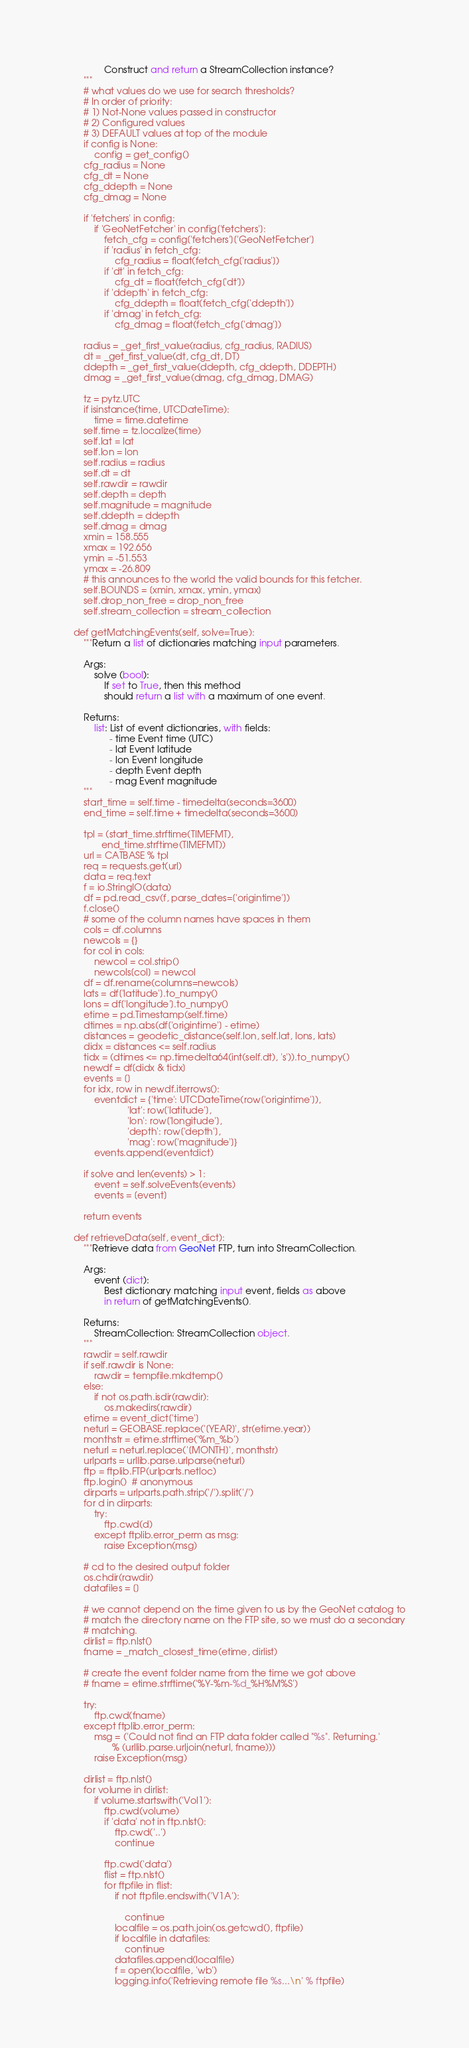Convert code to text. <code><loc_0><loc_0><loc_500><loc_500><_Python_>                Construct and return a StreamCollection instance?
        """
        # what values do we use for search thresholds?
        # In order of priority:
        # 1) Not-None values passed in constructor
        # 2) Configured values
        # 3) DEFAULT values at top of the module
        if config is None:
            config = get_config()
        cfg_radius = None
        cfg_dt = None
        cfg_ddepth = None
        cfg_dmag = None

        if 'fetchers' in config:
            if 'GeoNetFetcher' in config['fetchers']:
                fetch_cfg = config['fetchers']['GeoNetFetcher']
                if 'radius' in fetch_cfg:
                    cfg_radius = float(fetch_cfg['radius'])
                if 'dt' in fetch_cfg:
                    cfg_dt = float(fetch_cfg['dt'])
                if 'ddepth' in fetch_cfg:
                    cfg_ddepth = float(fetch_cfg['ddepth'])
                if 'dmag' in fetch_cfg:
                    cfg_dmag = float(fetch_cfg['dmag'])

        radius = _get_first_value(radius, cfg_radius, RADIUS)
        dt = _get_first_value(dt, cfg_dt, DT)
        ddepth = _get_first_value(ddepth, cfg_ddepth, DDEPTH)
        dmag = _get_first_value(dmag, cfg_dmag, DMAG)

        tz = pytz.UTC
        if isinstance(time, UTCDateTime):
            time = time.datetime
        self.time = tz.localize(time)
        self.lat = lat
        self.lon = lon
        self.radius = radius
        self.dt = dt
        self.rawdir = rawdir
        self.depth = depth
        self.magnitude = magnitude
        self.ddepth = ddepth
        self.dmag = dmag
        xmin = 158.555
        xmax = 192.656
        ymin = -51.553
        ymax = -26.809
        # this announces to the world the valid bounds for this fetcher.
        self.BOUNDS = [xmin, xmax, ymin, ymax]
        self.drop_non_free = drop_non_free
        self.stream_collection = stream_collection

    def getMatchingEvents(self, solve=True):
        """Return a list of dictionaries matching input parameters.

        Args:
            solve (bool):
                If set to True, then this method
                should return a list with a maximum of one event.

        Returns:
            list: List of event dictionaries, with fields:
                  - time Event time (UTC)
                  - lat Event latitude
                  - lon Event longitude
                  - depth Event depth
                  - mag Event magnitude
        """
        start_time = self.time - timedelta(seconds=3600)
        end_time = self.time + timedelta(seconds=3600)

        tpl = (start_time.strftime(TIMEFMT),
               end_time.strftime(TIMEFMT))
        url = CATBASE % tpl
        req = requests.get(url)
        data = req.text
        f = io.StringIO(data)
        df = pd.read_csv(f, parse_dates=['origintime'])
        f.close()
        # some of the column names have spaces in them
        cols = df.columns
        newcols = {}
        for col in cols:
            newcol = col.strip()
            newcols[col] = newcol
        df = df.rename(columns=newcols)
        lats = df['latitude'].to_numpy()
        lons = df['longitude'].to_numpy()
        etime = pd.Timestamp(self.time)
        dtimes = np.abs(df['origintime'] - etime)
        distances = geodetic_distance(self.lon, self.lat, lons, lats)
        didx = distances <= self.radius
        tidx = (dtimes <= np.timedelta64(int(self.dt), 's')).to_numpy()
        newdf = df[didx & tidx]
        events = []
        for idx, row in newdf.iterrows():
            eventdict = {'time': UTCDateTime(row['origintime']),
                         'lat': row['latitude'],
                         'lon': row['longitude'],
                         'depth': row['depth'],
                         'mag': row['magnitude']}
            events.append(eventdict)

        if solve and len(events) > 1:
            event = self.solveEvents(events)
            events = [event]

        return events

    def retrieveData(self, event_dict):
        """Retrieve data from GeoNet FTP, turn into StreamCollection.

        Args:
            event (dict):
                Best dictionary matching input event, fields as above
                in return of getMatchingEvents().

        Returns:
            StreamCollection: StreamCollection object.
        """
        rawdir = self.rawdir
        if self.rawdir is None:
            rawdir = tempfile.mkdtemp()
        else:
            if not os.path.isdir(rawdir):
                os.makedirs(rawdir)
        etime = event_dict['time']
        neturl = GEOBASE.replace('[YEAR]', str(etime.year))
        monthstr = etime.strftime('%m_%b')
        neturl = neturl.replace('[MONTH]', monthstr)
        urlparts = urllib.parse.urlparse(neturl)
        ftp = ftplib.FTP(urlparts.netloc)
        ftp.login()  # anonymous
        dirparts = urlparts.path.strip('/').split('/')
        for d in dirparts:
            try:
                ftp.cwd(d)
            except ftplib.error_perm as msg:
                raise Exception(msg)

        # cd to the desired output folder
        os.chdir(rawdir)
        datafiles = []

        # we cannot depend on the time given to us by the GeoNet catalog to
        # match the directory name on the FTP site, so we must do a secondary
        # matching.
        dirlist = ftp.nlst()
        fname = _match_closest_time(etime, dirlist)

        # create the event folder name from the time we got above
        # fname = etime.strftime('%Y-%m-%d_%H%M%S')

        try:
            ftp.cwd(fname)
        except ftplib.error_perm:
            msg = ('Could not find an FTP data folder called "%s". Returning.'
                   % (urllib.parse.urljoin(neturl, fname)))
            raise Exception(msg)

        dirlist = ftp.nlst()
        for volume in dirlist:
            if volume.startswith('Vol1'):
                ftp.cwd(volume)
                if 'data' not in ftp.nlst():
                    ftp.cwd('..')
                    continue

                ftp.cwd('data')
                flist = ftp.nlst()
                for ftpfile in flist:
                    if not ftpfile.endswith('V1A'):

                        continue
                    localfile = os.path.join(os.getcwd(), ftpfile)
                    if localfile in datafiles:
                        continue
                    datafiles.append(localfile)
                    f = open(localfile, 'wb')
                    logging.info('Retrieving remote file %s...\n' % ftpfile)</code> 